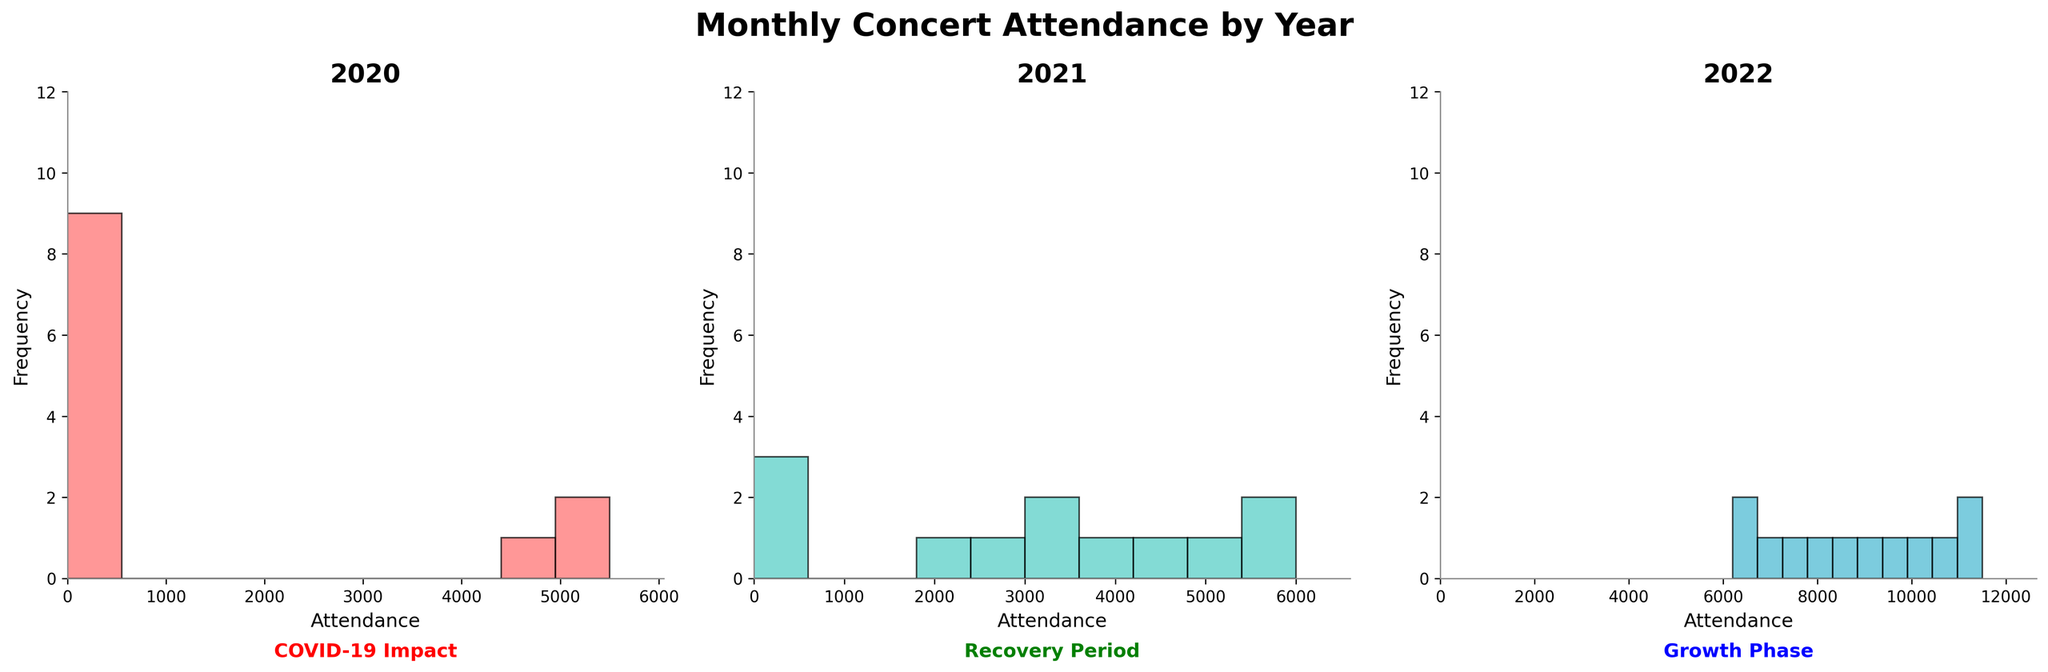How many months are displayed in the 2020 subplot? The title of the subplot is "Monthly Concert Attendance by Year 2020". Each bin in the histogram represents concert attendance for a month.
Answer: 12 Which year shows the highest maximum attendance in any month? Looking at the histograms, 2022 shows the highest bin representing an attendance of around 11500 in December.
Answer: 2022 What is the attendance frequency in April 2021? In 2021, the April attendance is represented by a bin around 2000. Since each attendance corresponds to one frequency in this histogram, it's 1.
Answer: 1 What is the most frequent attendance in the 2022 subplot? Looking at the histogram for 2022, no attendance occurs more than once, so each bin has a frequency of 1. Thus all attendances are equally frequent.
Answer: All attendances are equally frequent Compare the number of zero-attendance months in 2020 and 2021 2020 has zero-attendance for all months from April to December (9 months). In 2021, only January, February, and March have zero-attendance (3 months).
Answer: 2020 has 6 more zero-attendance months than 2021 State the main reason indicated for the zero attendances in 2020 The text below the 2020 subplot mentions “COVID-19 Impact” as the reason for zero attendance.
Answer: COVID-19 Impact How does the recovery phase in 2021 relate to the COVID-19 impact in 2020? By comparing the attendance figures, there is zero attendance for essentially all of 2020 while attendance figures begin to recover starting from April 2021 as indicated by the text "Recovery Period".
Answer: Attendance starts to recover in 2021 What colors represent each subplot's bars? The first subplot (2020) uses red bars, the second subplot (2021) uses green bars, and the third subplot (2022) uses blue bars.
Answer: Red (2020), Green (2021), Blue (2022) What is the trend of the maximum attendance from 2020 to 2022? The histograms show 2020 with a max attendance of around 5500, 2021 peaks at 6000, and 2022 at 11500. There is a noticeable upward trend each year.
Answer: Increasing trend 